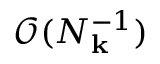Convert formula to latex. <formula><loc_0><loc_0><loc_500><loc_500>\mathcal { O } ( N _ { k } ^ { - 1 } )</formula> 